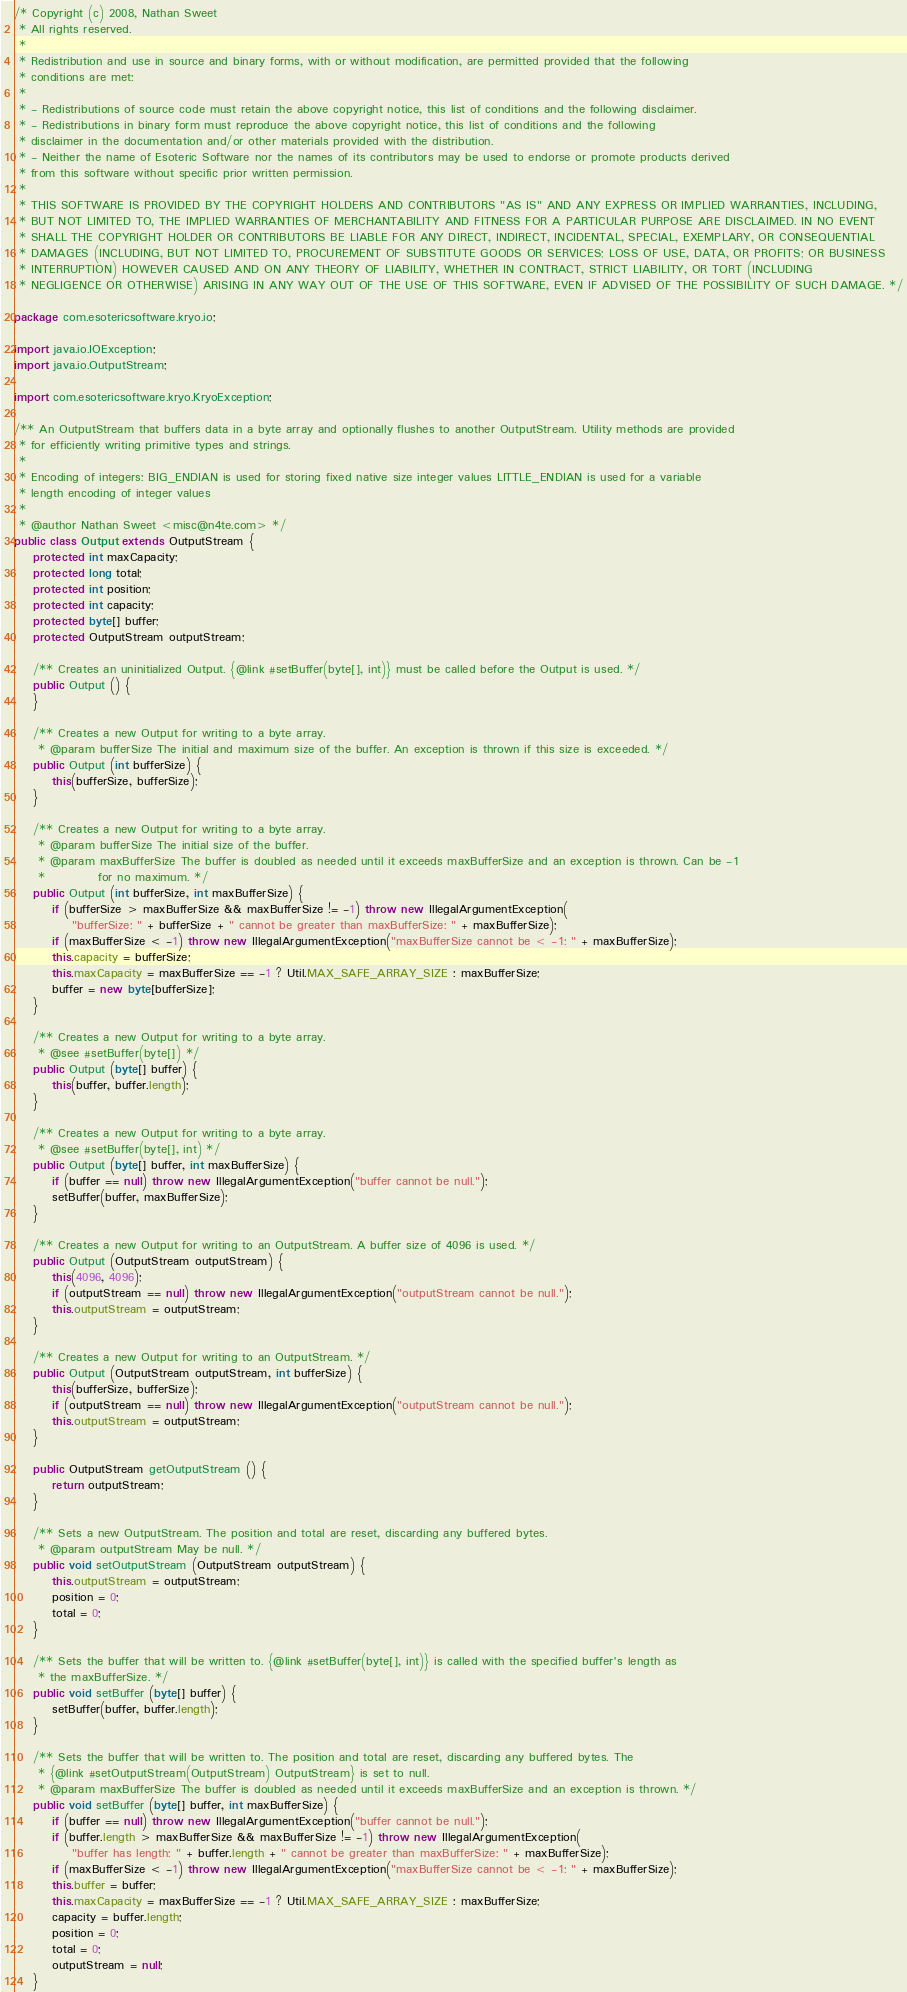<code> <loc_0><loc_0><loc_500><loc_500><_Java_>/* Copyright (c) 2008, Nathan Sweet
 * All rights reserved.
 * 
 * Redistribution and use in source and binary forms, with or without modification, are permitted provided that the following
 * conditions are met:
 * 
 * - Redistributions of source code must retain the above copyright notice, this list of conditions and the following disclaimer.
 * - Redistributions in binary form must reproduce the above copyright notice, this list of conditions and the following
 * disclaimer in the documentation and/or other materials provided with the distribution.
 * - Neither the name of Esoteric Software nor the names of its contributors may be used to endorse or promote products derived
 * from this software without specific prior written permission.
 * 
 * THIS SOFTWARE IS PROVIDED BY THE COPYRIGHT HOLDERS AND CONTRIBUTORS "AS IS" AND ANY EXPRESS OR IMPLIED WARRANTIES, INCLUDING,
 * BUT NOT LIMITED TO, THE IMPLIED WARRANTIES OF MERCHANTABILITY AND FITNESS FOR A PARTICULAR PURPOSE ARE DISCLAIMED. IN NO EVENT
 * SHALL THE COPYRIGHT HOLDER OR CONTRIBUTORS BE LIABLE FOR ANY DIRECT, INDIRECT, INCIDENTAL, SPECIAL, EXEMPLARY, OR CONSEQUENTIAL
 * DAMAGES (INCLUDING, BUT NOT LIMITED TO, PROCUREMENT OF SUBSTITUTE GOODS OR SERVICES; LOSS OF USE, DATA, OR PROFITS; OR BUSINESS
 * INTERRUPTION) HOWEVER CAUSED AND ON ANY THEORY OF LIABILITY, WHETHER IN CONTRACT, STRICT LIABILITY, OR TORT (INCLUDING
 * NEGLIGENCE OR OTHERWISE) ARISING IN ANY WAY OUT OF THE USE OF THIS SOFTWARE, EVEN IF ADVISED OF THE POSSIBILITY OF SUCH DAMAGE. */

package com.esotericsoftware.kryo.io;

import java.io.IOException;
import java.io.OutputStream;

import com.esotericsoftware.kryo.KryoException;

/** An OutputStream that buffers data in a byte array and optionally flushes to another OutputStream. Utility methods are provided
 * for efficiently writing primitive types and strings.
 * 
 * Encoding of integers: BIG_ENDIAN is used for storing fixed native size integer values LITTLE_ENDIAN is used for a variable
 * length encoding of integer values
 * 
 * @author Nathan Sweet <misc@n4te.com> */
public class Output extends OutputStream {
	protected int maxCapacity;
	protected long total;
	protected int position;
	protected int capacity;
	protected byte[] buffer;
	protected OutputStream outputStream;

	/** Creates an uninitialized Output. {@link #setBuffer(byte[], int)} must be called before the Output is used. */
	public Output () {
	}

	/** Creates a new Output for writing to a byte array.
	 * @param bufferSize The initial and maximum size of the buffer. An exception is thrown if this size is exceeded. */
	public Output (int bufferSize) {
		this(bufferSize, bufferSize);
	}

	/** Creates a new Output for writing to a byte array.
	 * @param bufferSize The initial size of the buffer.
	 * @param maxBufferSize The buffer is doubled as needed until it exceeds maxBufferSize and an exception is thrown. Can be -1
	 *           for no maximum. */
	public Output (int bufferSize, int maxBufferSize) {
		if (bufferSize > maxBufferSize && maxBufferSize != -1) throw new IllegalArgumentException(
			"bufferSize: " + bufferSize + " cannot be greater than maxBufferSize: " + maxBufferSize);
		if (maxBufferSize < -1) throw new IllegalArgumentException("maxBufferSize cannot be < -1: " + maxBufferSize);
		this.capacity = bufferSize;
		this.maxCapacity = maxBufferSize == -1 ? Util.MAX_SAFE_ARRAY_SIZE : maxBufferSize;
		buffer = new byte[bufferSize];
	}

	/** Creates a new Output for writing to a byte array.
	 * @see #setBuffer(byte[]) */
	public Output (byte[] buffer) {
		this(buffer, buffer.length);
	}

	/** Creates a new Output for writing to a byte array.
	 * @see #setBuffer(byte[], int) */
	public Output (byte[] buffer, int maxBufferSize) {
		if (buffer == null) throw new IllegalArgumentException("buffer cannot be null.");
		setBuffer(buffer, maxBufferSize);
	}

	/** Creates a new Output for writing to an OutputStream. A buffer size of 4096 is used. */
	public Output (OutputStream outputStream) {
		this(4096, 4096);
		if (outputStream == null) throw new IllegalArgumentException("outputStream cannot be null.");
		this.outputStream = outputStream;
	}

	/** Creates a new Output for writing to an OutputStream. */
	public Output (OutputStream outputStream, int bufferSize) {
		this(bufferSize, bufferSize);
		if (outputStream == null) throw new IllegalArgumentException("outputStream cannot be null.");
		this.outputStream = outputStream;
	}

	public OutputStream getOutputStream () {
		return outputStream;
	}

	/** Sets a new OutputStream. The position and total are reset, discarding any buffered bytes.
	 * @param outputStream May be null. */
	public void setOutputStream (OutputStream outputStream) {
		this.outputStream = outputStream;
		position = 0;
		total = 0;
	}

	/** Sets the buffer that will be written to. {@link #setBuffer(byte[], int)} is called with the specified buffer's length as
	 * the maxBufferSize. */
	public void setBuffer (byte[] buffer) {
		setBuffer(buffer, buffer.length);
	}

	/** Sets the buffer that will be written to. The position and total are reset, discarding any buffered bytes. The
	 * {@link #setOutputStream(OutputStream) OutputStream} is set to null.
	 * @param maxBufferSize The buffer is doubled as needed until it exceeds maxBufferSize and an exception is thrown. */
	public void setBuffer (byte[] buffer, int maxBufferSize) {
		if (buffer == null) throw new IllegalArgumentException("buffer cannot be null.");
		if (buffer.length > maxBufferSize && maxBufferSize != -1) throw new IllegalArgumentException(
			"buffer has length: " + buffer.length + " cannot be greater than maxBufferSize: " + maxBufferSize);
		if (maxBufferSize < -1) throw new IllegalArgumentException("maxBufferSize cannot be < -1: " + maxBufferSize);
		this.buffer = buffer;
		this.maxCapacity = maxBufferSize == -1 ? Util.MAX_SAFE_ARRAY_SIZE : maxBufferSize;
		capacity = buffer.length;
		position = 0;
		total = 0;
		outputStream = null;
	}
</code> 